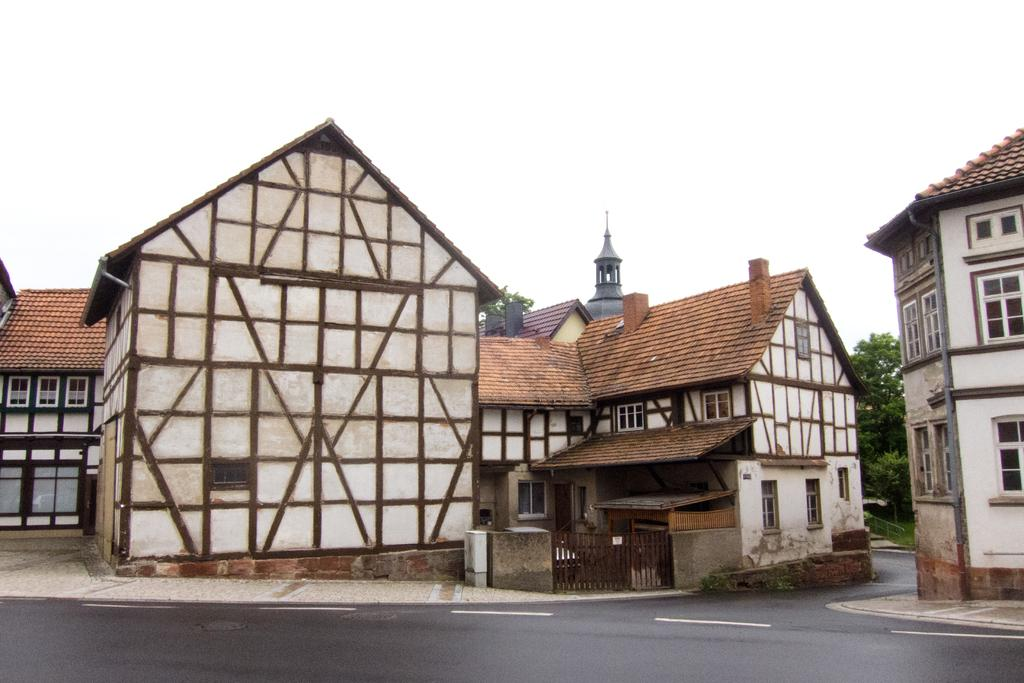What type of buildings are in the image? There are white shed houses in the image. What color are the roof tiles of the shed houses? The shed houses have brown roof tiles. What can be seen running through the image? There is a road visible in the image. What is visible at the top of the image? The sky is visible at the top of the image. What type of society is depicted in the image? The image does not depict a society; it features white shed houses, a road, and the sky. Who is the writer of the shed houses in the image? There is no writer associated with the shed houses in the image; they are simply buildings. 